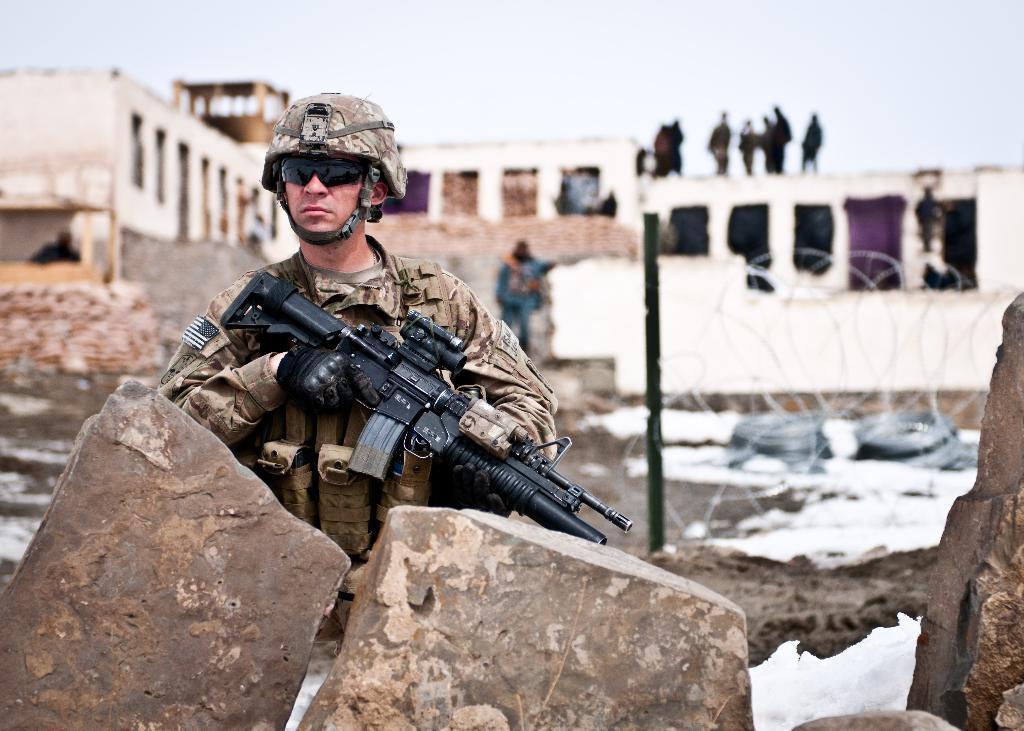Could you give a brief overview of what you see in this image? In this picture we can see a person standing behind the stone. He is in military dress he is holding a gun with his hand. And he wore gloves, goggles, and cap. And on the background there is a building and some people are standing on the building. This is the pole. And on the background there is a sky. 